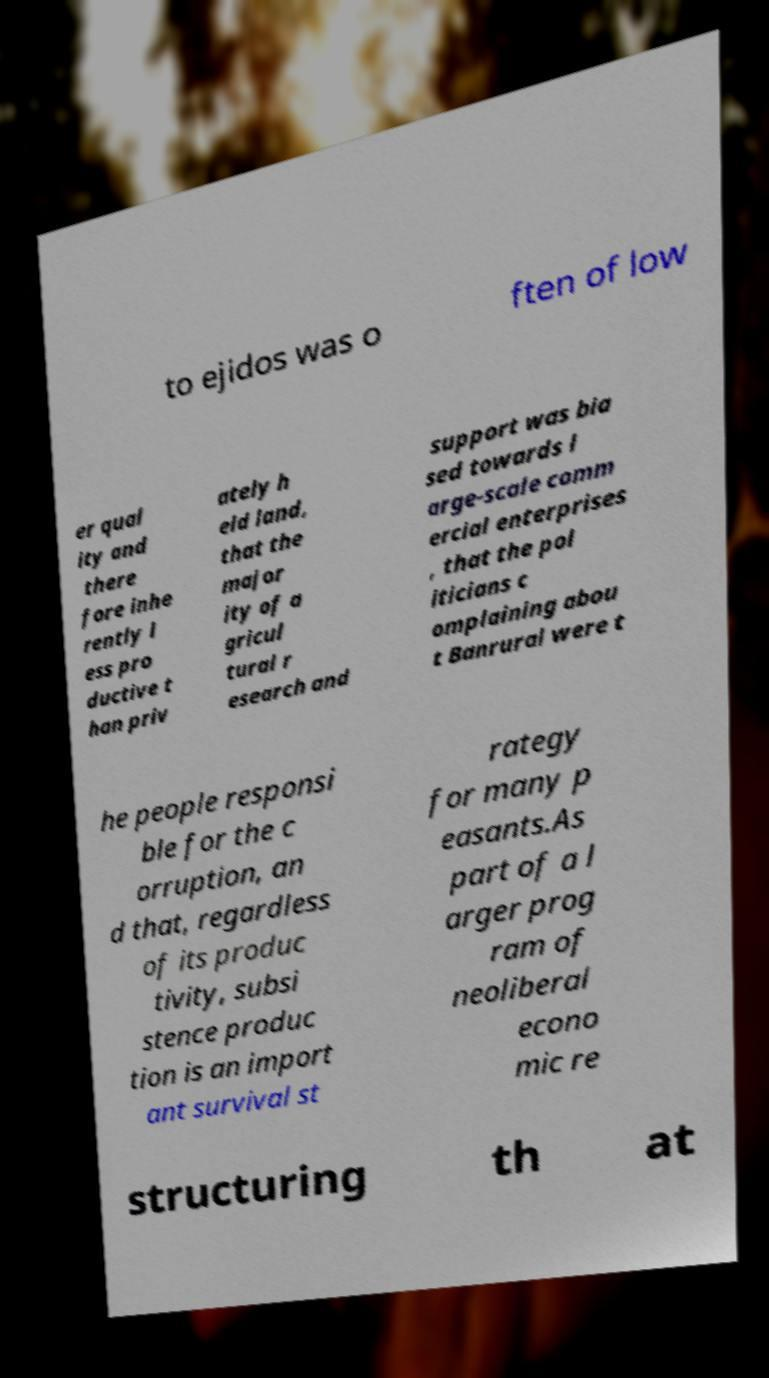What messages or text are displayed in this image? I need them in a readable, typed format. to ejidos was o ften of low er qual ity and there fore inhe rently l ess pro ductive t han priv ately h eld land, that the major ity of a gricul tural r esearch and support was bia sed towards l arge-scale comm ercial enterprises , that the pol iticians c omplaining abou t Banrural were t he people responsi ble for the c orruption, an d that, regardless of its produc tivity, subsi stence produc tion is an import ant survival st rategy for many p easants.As part of a l arger prog ram of neoliberal econo mic re structuring th at 